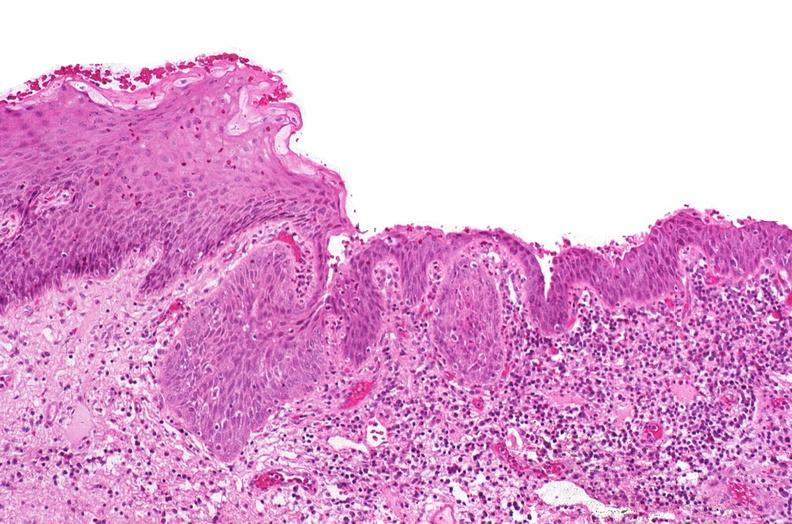s urinary present?
Answer the question using a single word or phrase. Yes 